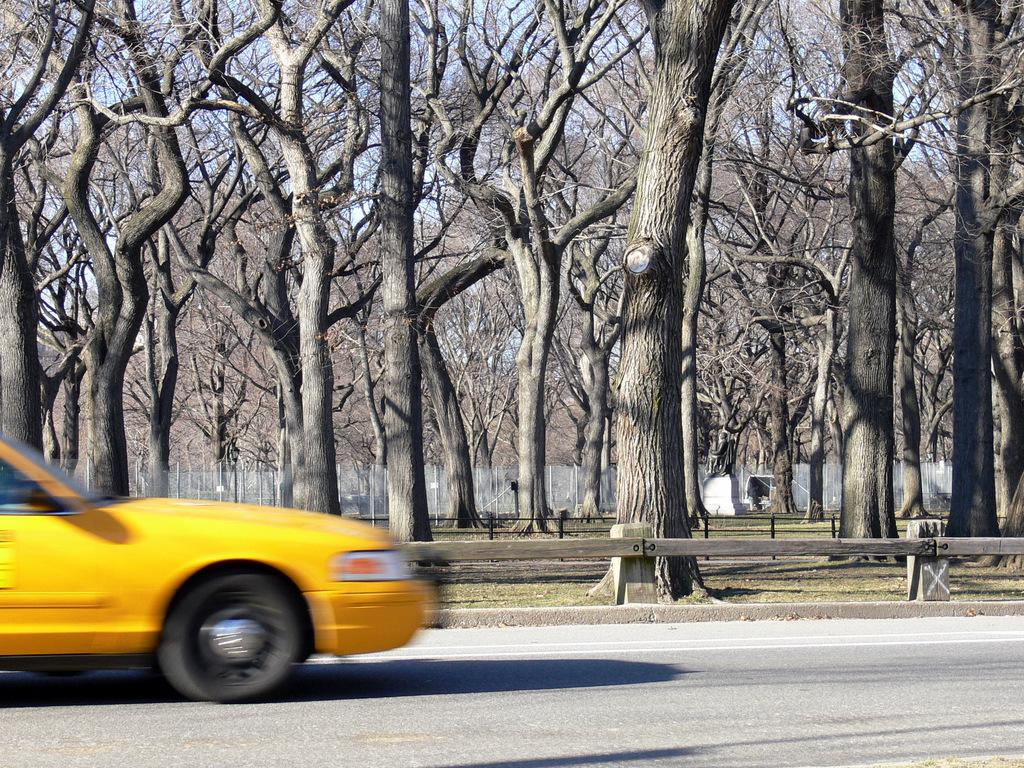What is the main subject in the foreground of the image? There is a car in the foreground of the image. Where is the car located? The car is on the road. What can be seen in the center of the image? There are trees and railing in the center of the image. What is visible in the background of the image? There is fencing in the background of the image. How would you describe the weather in the image? The weather is sunny. What type of drum can be heard playing in the background of the image? There is no drum present in the image, and therefore no sound can be heard. 